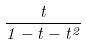<formula> <loc_0><loc_0><loc_500><loc_500>\frac { t } { 1 - t - t ^ { 2 } }</formula> 